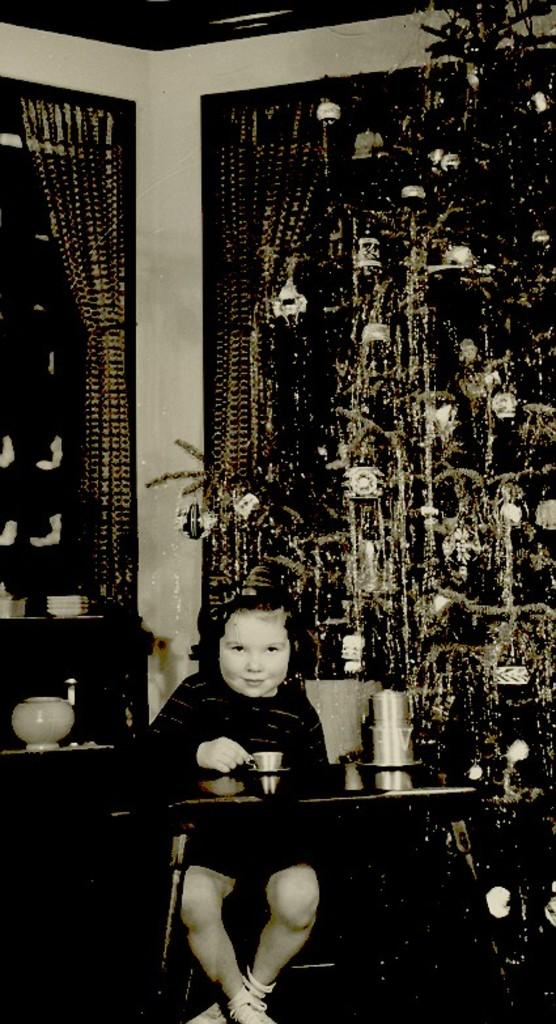What type of tree is in the image? There is a Christmas tree in the image. What type of window treatment is visible in the image? There are curtains in the image. What is the boy in the image doing? The boy is sitting on a chair in the image. What furniture is present in the image? There is a table in the image. What items can be seen on the table? There are glasses and a cup on the table. What type of gold vein can be seen running through the cup in the image? There is no gold vein present in the image, and the cup does not have any visible veins. 